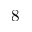<formula> <loc_0><loc_0><loc_500><loc_500>8</formula> 